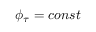<formula> <loc_0><loc_0><loc_500><loc_500>\phi _ { \tau } = c o n s t</formula> 